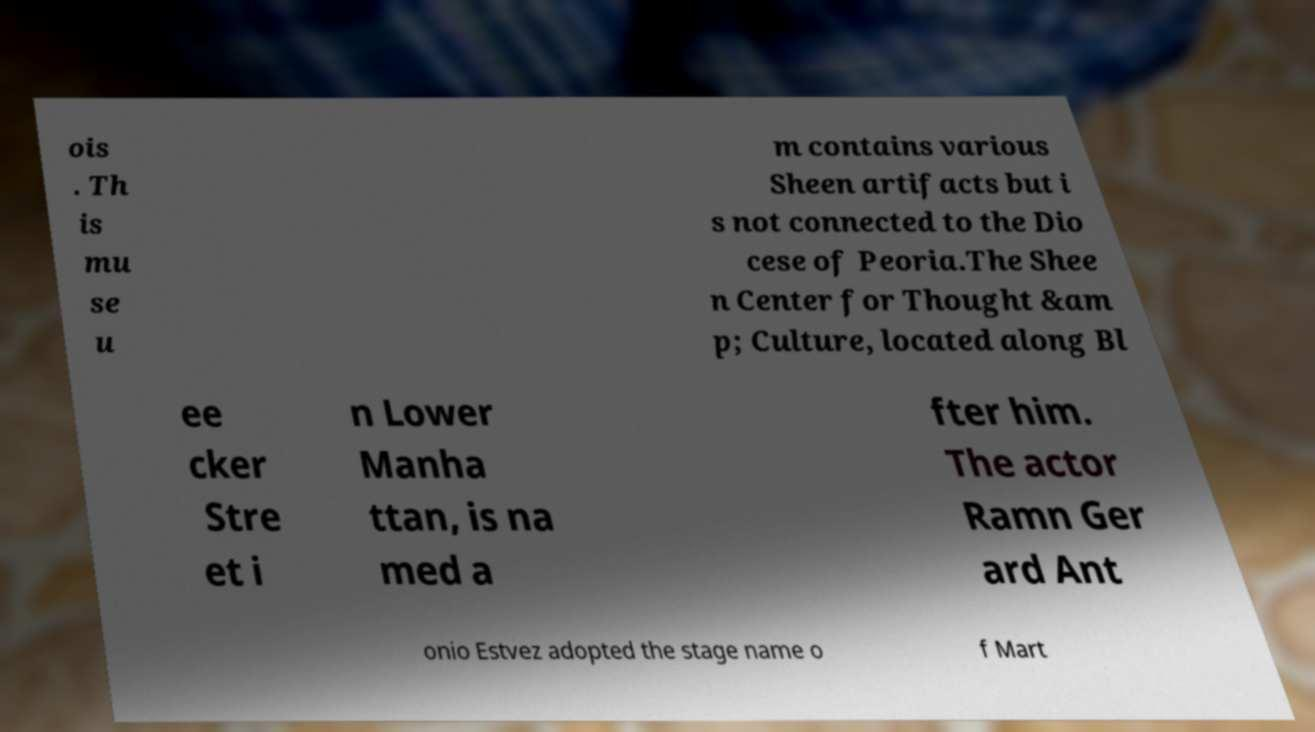For documentation purposes, I need the text within this image transcribed. Could you provide that? ois . Th is mu se u m contains various Sheen artifacts but i s not connected to the Dio cese of Peoria.The Shee n Center for Thought &am p; Culture, located along Bl ee cker Stre et i n Lower Manha ttan, is na med a fter him. The actor Ramn Ger ard Ant onio Estvez adopted the stage name o f Mart 